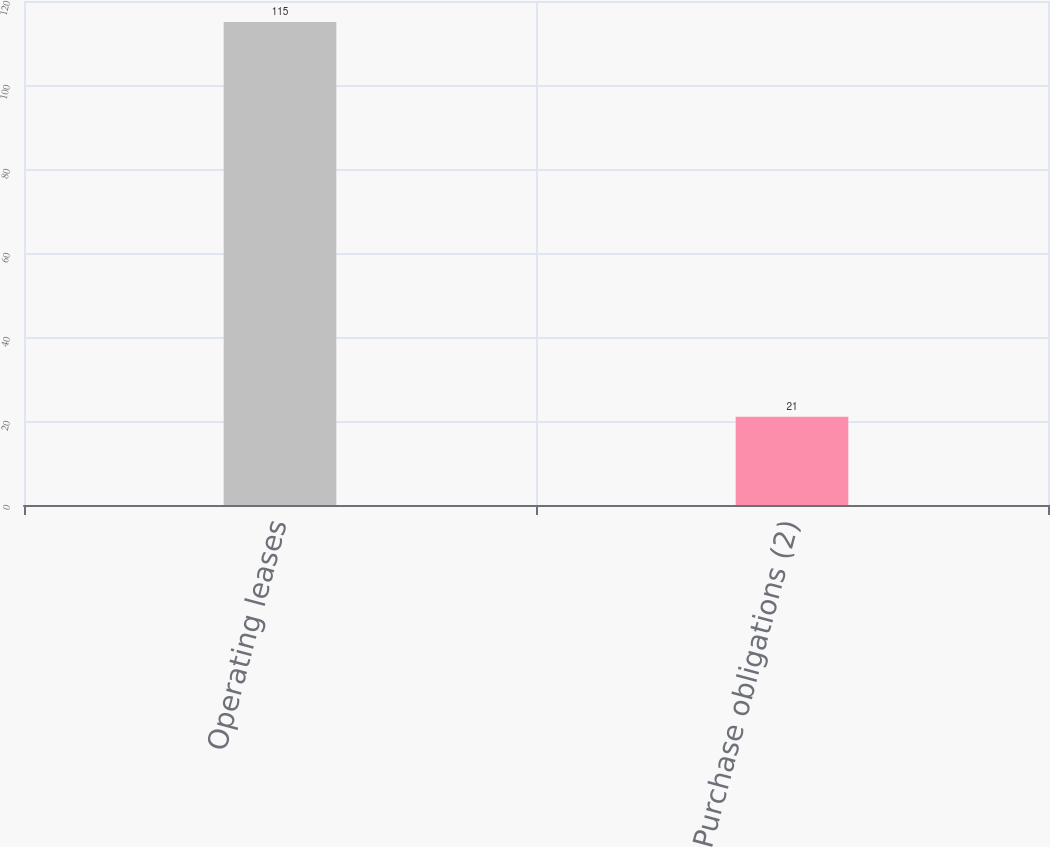<chart> <loc_0><loc_0><loc_500><loc_500><bar_chart><fcel>Operating leases<fcel>Purchase obligations (2)<nl><fcel>115<fcel>21<nl></chart> 